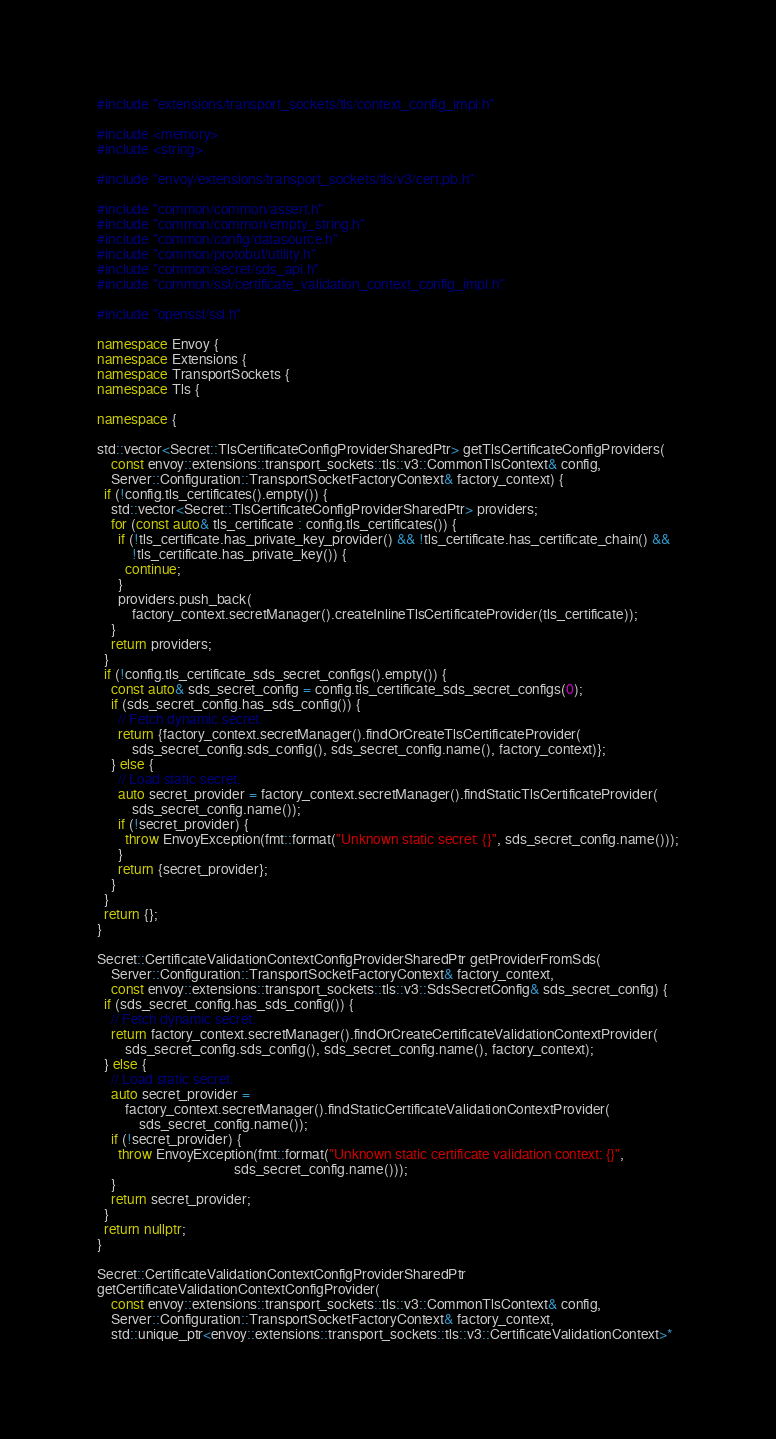<code> <loc_0><loc_0><loc_500><loc_500><_C++_>#include "extensions/transport_sockets/tls/context_config_impl.h"

#include <memory>
#include <string>

#include "envoy/extensions/transport_sockets/tls/v3/cert.pb.h"

#include "common/common/assert.h"
#include "common/common/empty_string.h"
#include "common/config/datasource.h"
#include "common/protobuf/utility.h"
#include "common/secret/sds_api.h"
#include "common/ssl/certificate_validation_context_config_impl.h"

#include "openssl/ssl.h"

namespace Envoy {
namespace Extensions {
namespace TransportSockets {
namespace Tls {

namespace {

std::vector<Secret::TlsCertificateConfigProviderSharedPtr> getTlsCertificateConfigProviders(
    const envoy::extensions::transport_sockets::tls::v3::CommonTlsContext& config,
    Server::Configuration::TransportSocketFactoryContext& factory_context) {
  if (!config.tls_certificates().empty()) {
    std::vector<Secret::TlsCertificateConfigProviderSharedPtr> providers;
    for (const auto& tls_certificate : config.tls_certificates()) {
      if (!tls_certificate.has_private_key_provider() && !tls_certificate.has_certificate_chain() &&
          !tls_certificate.has_private_key()) {
        continue;
      }
      providers.push_back(
          factory_context.secretManager().createInlineTlsCertificateProvider(tls_certificate));
    }
    return providers;
  }
  if (!config.tls_certificate_sds_secret_configs().empty()) {
    const auto& sds_secret_config = config.tls_certificate_sds_secret_configs(0);
    if (sds_secret_config.has_sds_config()) {
      // Fetch dynamic secret.
      return {factory_context.secretManager().findOrCreateTlsCertificateProvider(
          sds_secret_config.sds_config(), sds_secret_config.name(), factory_context)};
    } else {
      // Load static secret.
      auto secret_provider = factory_context.secretManager().findStaticTlsCertificateProvider(
          sds_secret_config.name());
      if (!secret_provider) {
        throw EnvoyException(fmt::format("Unknown static secret: {}", sds_secret_config.name()));
      }
      return {secret_provider};
    }
  }
  return {};
}

Secret::CertificateValidationContextConfigProviderSharedPtr getProviderFromSds(
    Server::Configuration::TransportSocketFactoryContext& factory_context,
    const envoy::extensions::transport_sockets::tls::v3::SdsSecretConfig& sds_secret_config) {
  if (sds_secret_config.has_sds_config()) {
    // Fetch dynamic secret.
    return factory_context.secretManager().findOrCreateCertificateValidationContextProvider(
        sds_secret_config.sds_config(), sds_secret_config.name(), factory_context);
  } else {
    // Load static secret.
    auto secret_provider =
        factory_context.secretManager().findStaticCertificateValidationContextProvider(
            sds_secret_config.name());
    if (!secret_provider) {
      throw EnvoyException(fmt::format("Unknown static certificate validation context: {}",
                                       sds_secret_config.name()));
    }
    return secret_provider;
  }
  return nullptr;
}

Secret::CertificateValidationContextConfigProviderSharedPtr
getCertificateValidationContextConfigProvider(
    const envoy::extensions::transport_sockets::tls::v3::CommonTlsContext& config,
    Server::Configuration::TransportSocketFactoryContext& factory_context,
    std::unique_ptr<envoy::extensions::transport_sockets::tls::v3::CertificateValidationContext>*</code> 